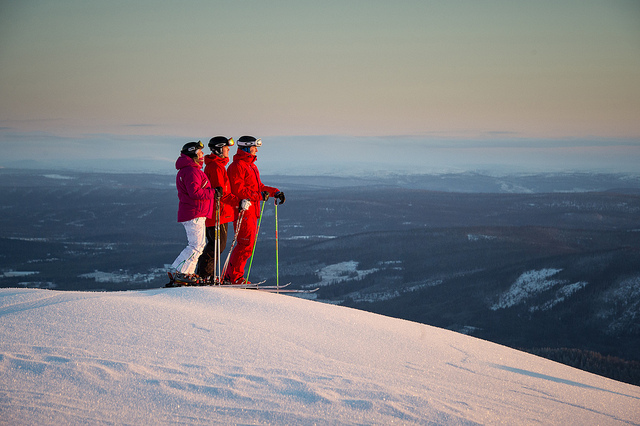Can you describe the environment beyond the skiers? Beyond the skiers stretches a vast, open landscape dotted with snow-covered hills and trees, fading into the horizon with a gradient of colors likely from the setting or rising sun. It appears to be a remote, mountainous region, ideal for winter sports. 